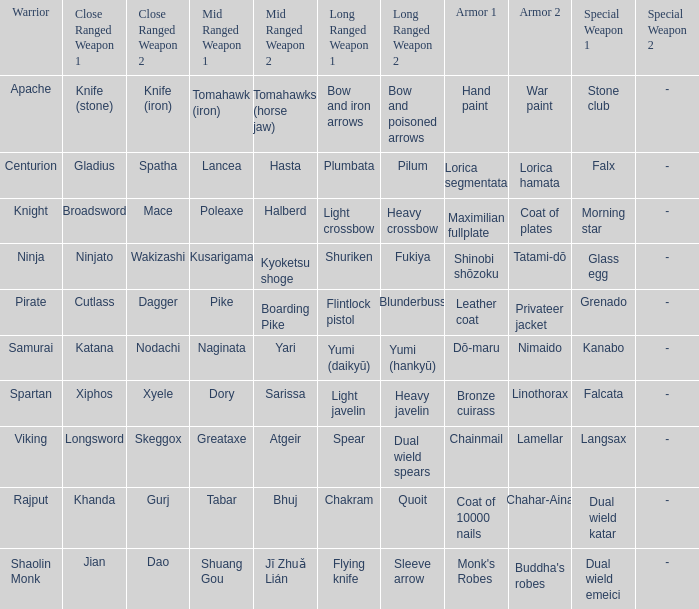If the special weapon is the Grenado, what is the armor? Leather coat, Privateer jacket. 